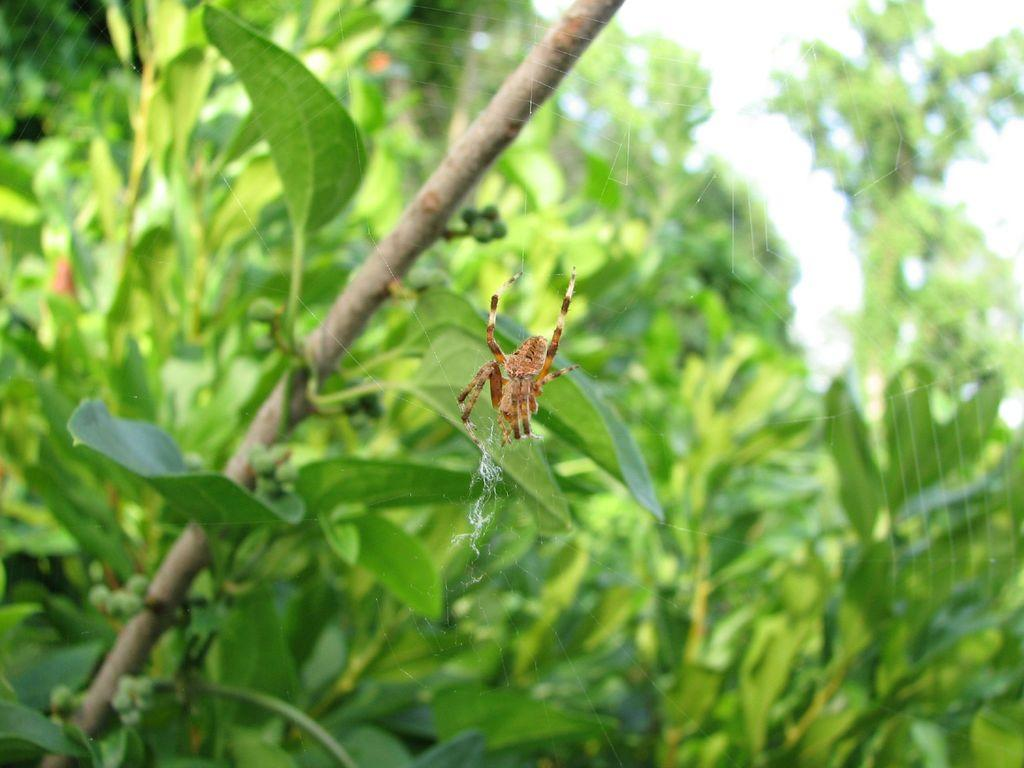What is the main subject of the image? The main subject of the image is a spider. Where is the spider located in the image? The spider is on a web. What can be seen in the background of the image? There are plants with leaves in the background of the image. What part of the sky is visible in the image? The sky is visible at the top right of the image. Can you tell me how many people are walking towards the church in the image? There is no church or people walking in the image; it features a spider on a web with plants and sky in the background. 